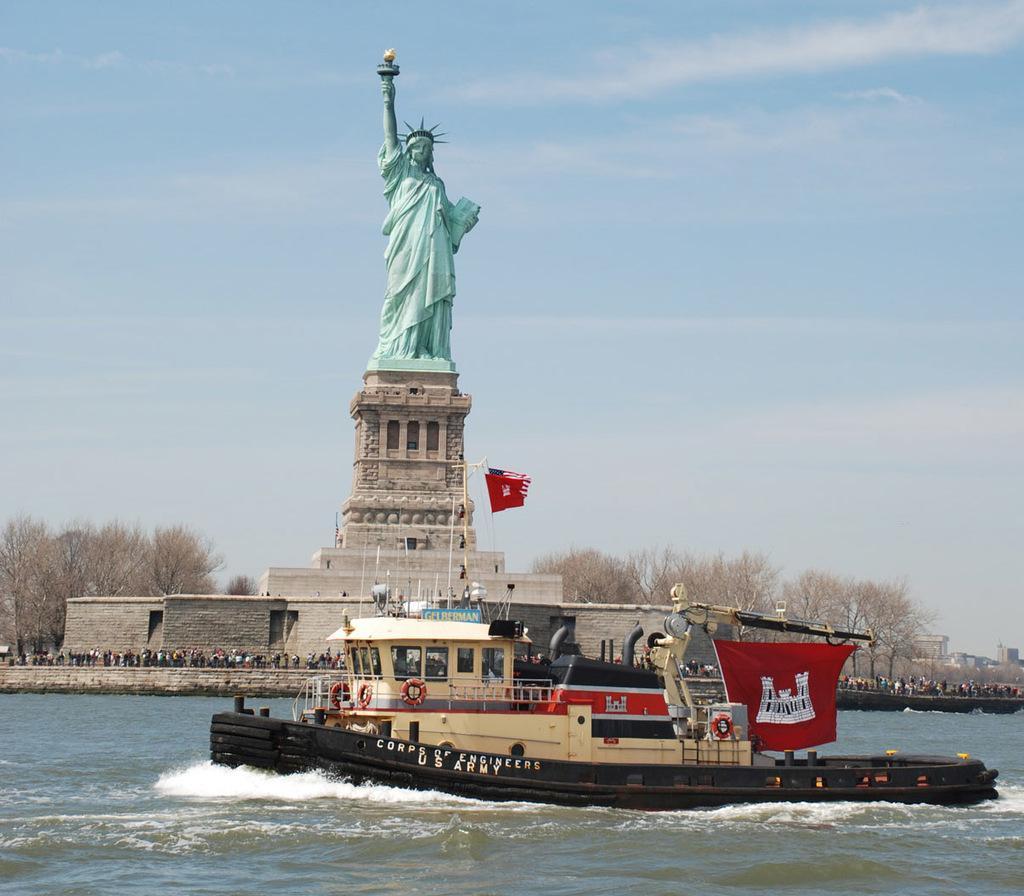Could you give a brief overview of what you see in this image? In the picture there is a statue of liberty and in front of the statue there is a huge crowd, in front of them a ship is sailing on the water and in the background there are few dry trees. 